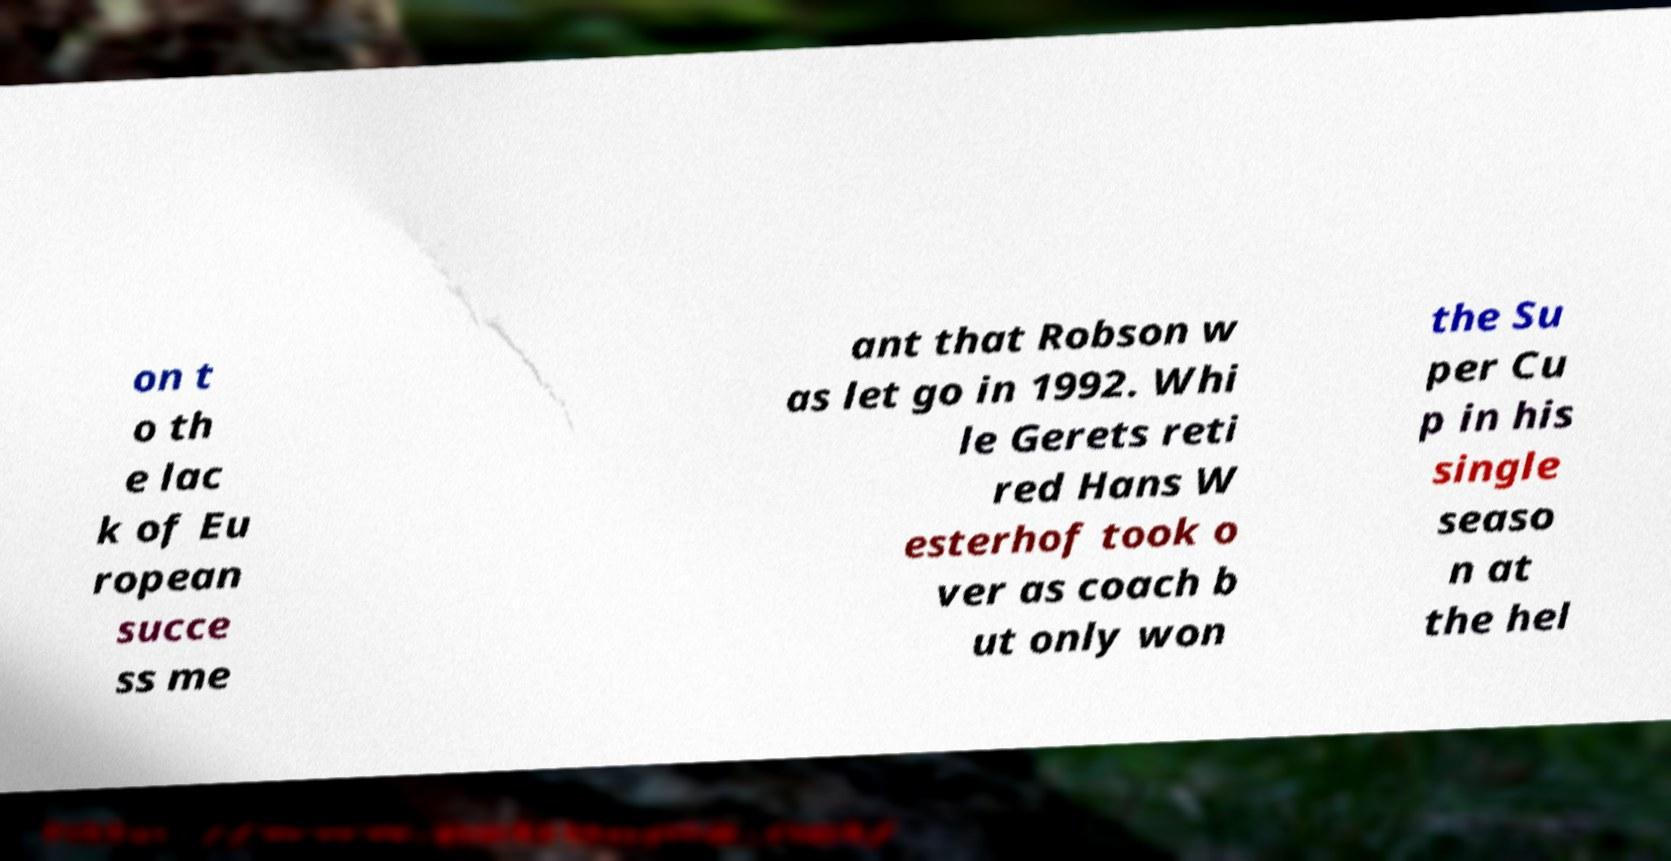What messages or text are displayed in this image? I need them in a readable, typed format. on t o th e lac k of Eu ropean succe ss me ant that Robson w as let go in 1992. Whi le Gerets reti red Hans W esterhof took o ver as coach b ut only won the Su per Cu p in his single seaso n at the hel 